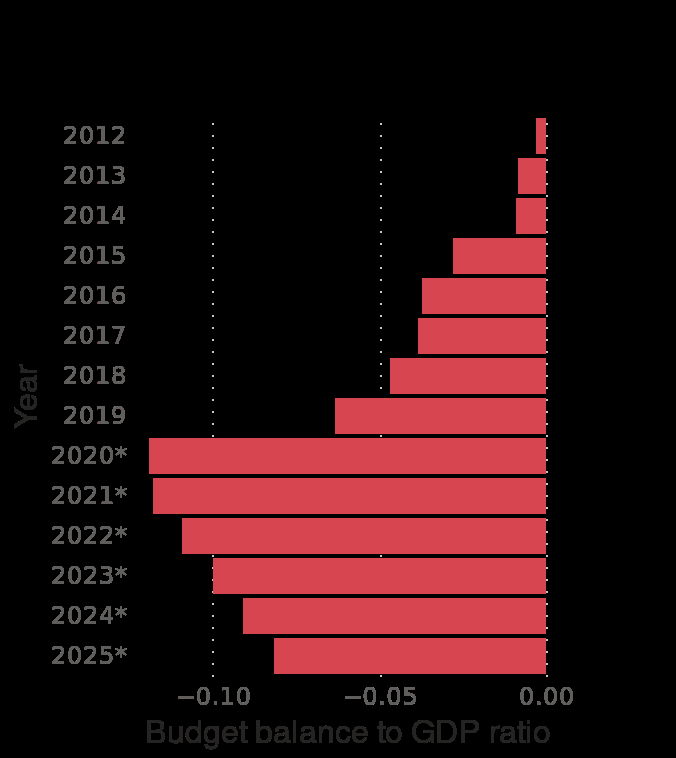<image>
please summary the statistics and relations of the chart The forecasted ratios for the years 2020 to 2025 show a marked increase in the minus budget balance before slowly improving. China's budget balance to GDP ratio was under -0.05 until 2019. How was China's budget balance to GDP ratio until 2019?  China's budget balance to GDP ratio was under -0.05 until 2019. Did China have a budget surplus to GDP ratio of over -0.05 until 2019? No. China's budget balance to GDP ratio was under -0.05 until 2019. 